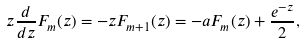Convert formula to latex. <formula><loc_0><loc_0><loc_500><loc_500>z \frac { d } { d z } F _ { m } ( z ) = - z F _ { m + 1 } ( z ) = - a F _ { m } ( z ) + \frac { e ^ { - z } } { 2 } ,</formula> 